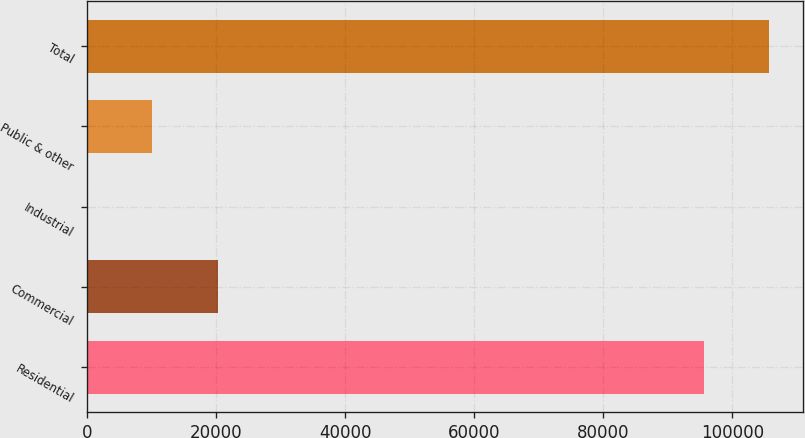Convert chart. <chart><loc_0><loc_0><loc_500><loc_500><bar_chart><fcel>Residential<fcel>Commercial<fcel>Industrial<fcel>Public & other<fcel>Total<nl><fcel>95576<fcel>20267.2<fcel>12<fcel>10139.6<fcel>105704<nl></chart> 